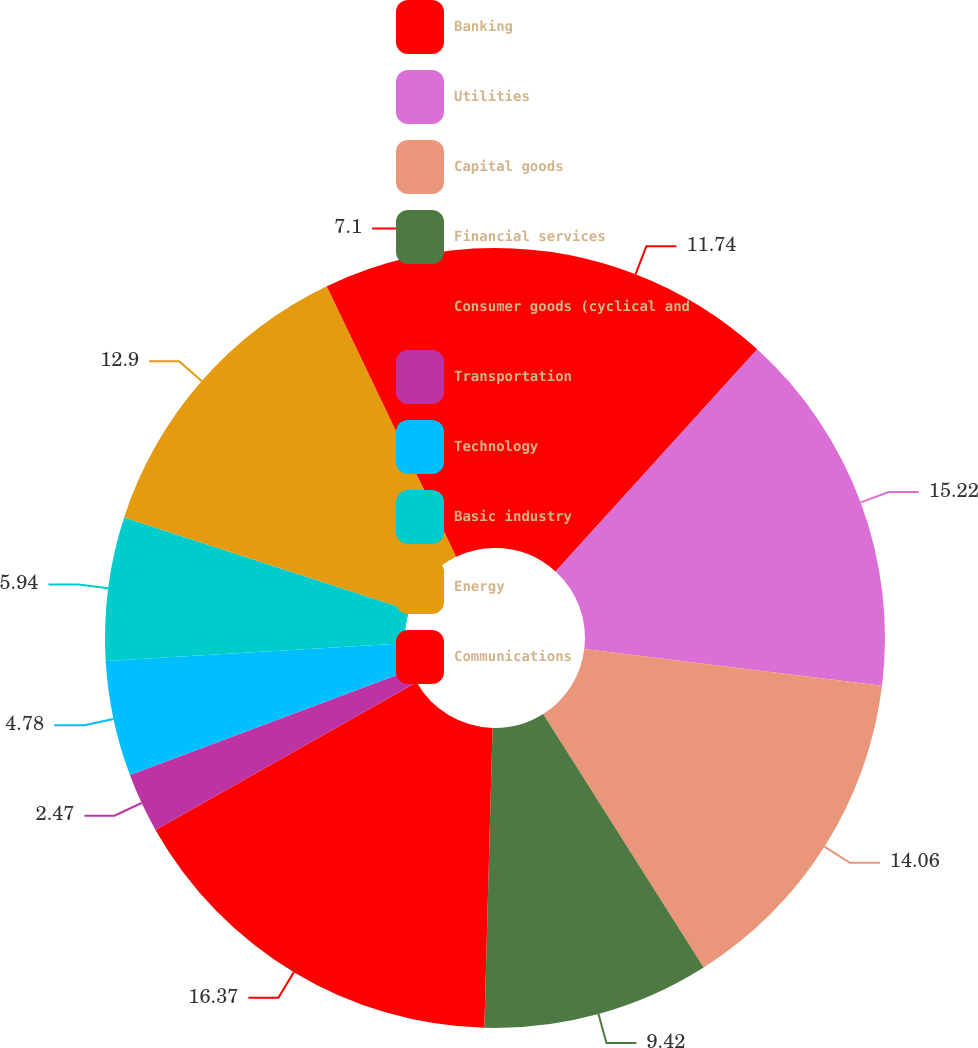<chart> <loc_0><loc_0><loc_500><loc_500><pie_chart><fcel>Banking<fcel>Utilities<fcel>Capital goods<fcel>Financial services<fcel>Consumer goods (cyclical and<fcel>Transportation<fcel>Technology<fcel>Basic industry<fcel>Energy<fcel>Communications<nl><fcel>11.74%<fcel>15.22%<fcel>14.06%<fcel>9.42%<fcel>16.38%<fcel>2.47%<fcel>4.78%<fcel>5.94%<fcel>12.9%<fcel>7.1%<nl></chart> 